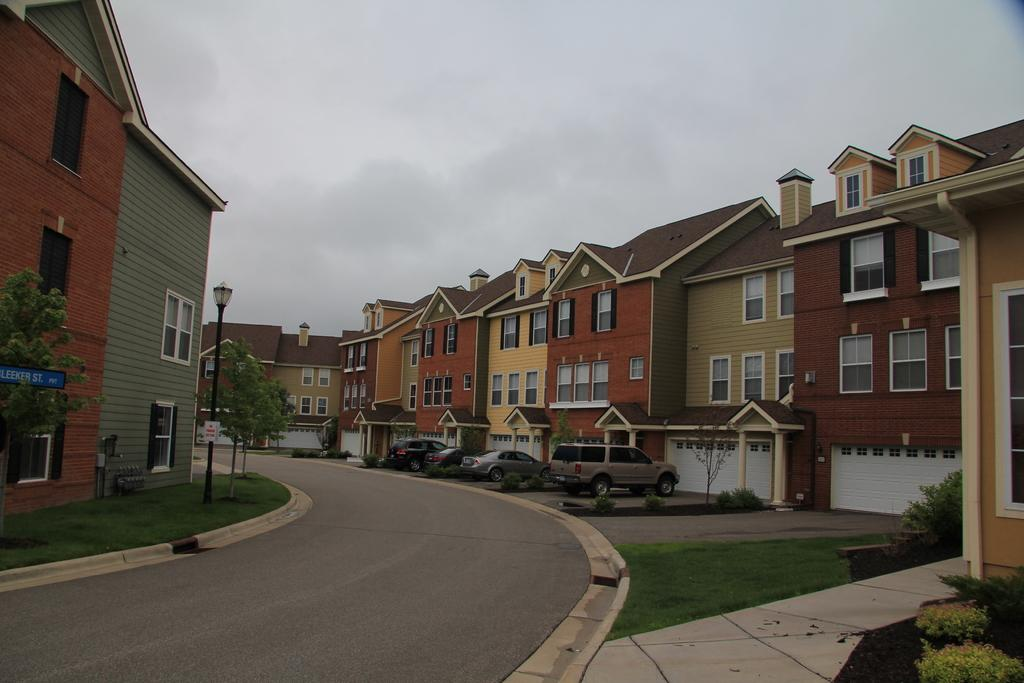What type of vegetation is present in the image? There is grass in the image. What structures can be seen in the image? There are poles, trees, and buildings in the image. What is the primary mode of transportation visible in the image? There are fleets of cars on the road in the image. What is visible at the top of the image? The sky is visible at the top of the image. What can be inferred about the location of the image? The image is likely taken on a road. What type of produce is being harvested in the image? There is no produce being harvested in the image; it features grass, poles, trees, buildings, cars, and the sky. Can you see any mist in the image? There is no mist visible in the image. 